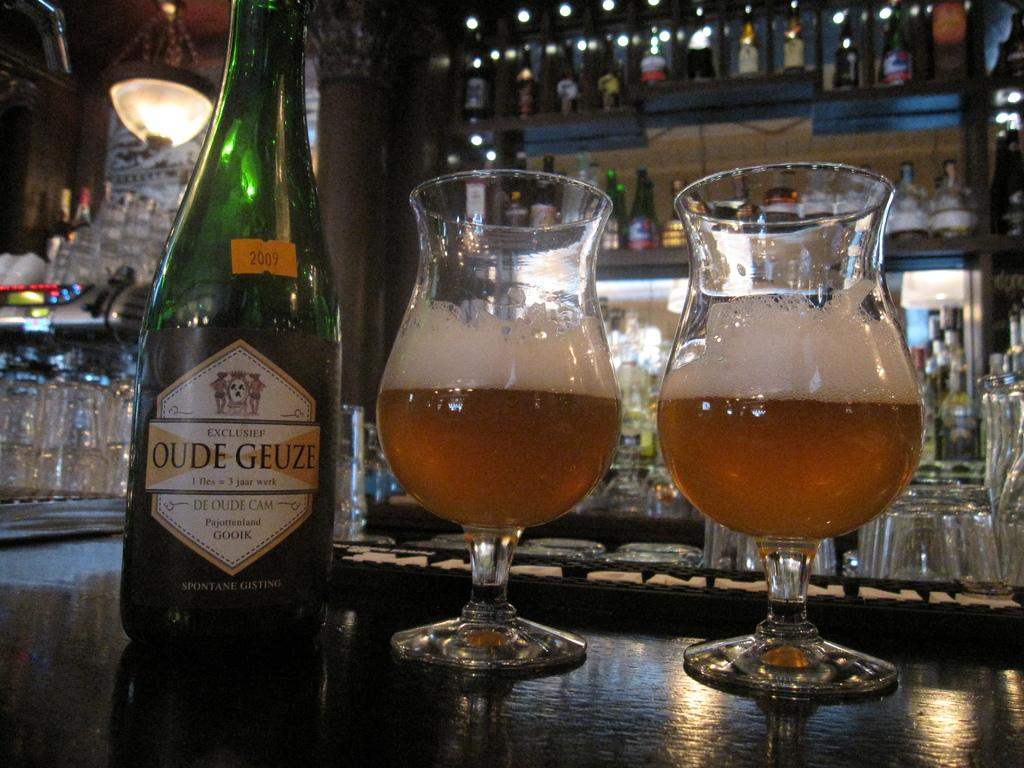<image>
Share a concise interpretation of the image provided. Two curvy half filled snifters next to a bottle of Oude Geuze beer. 